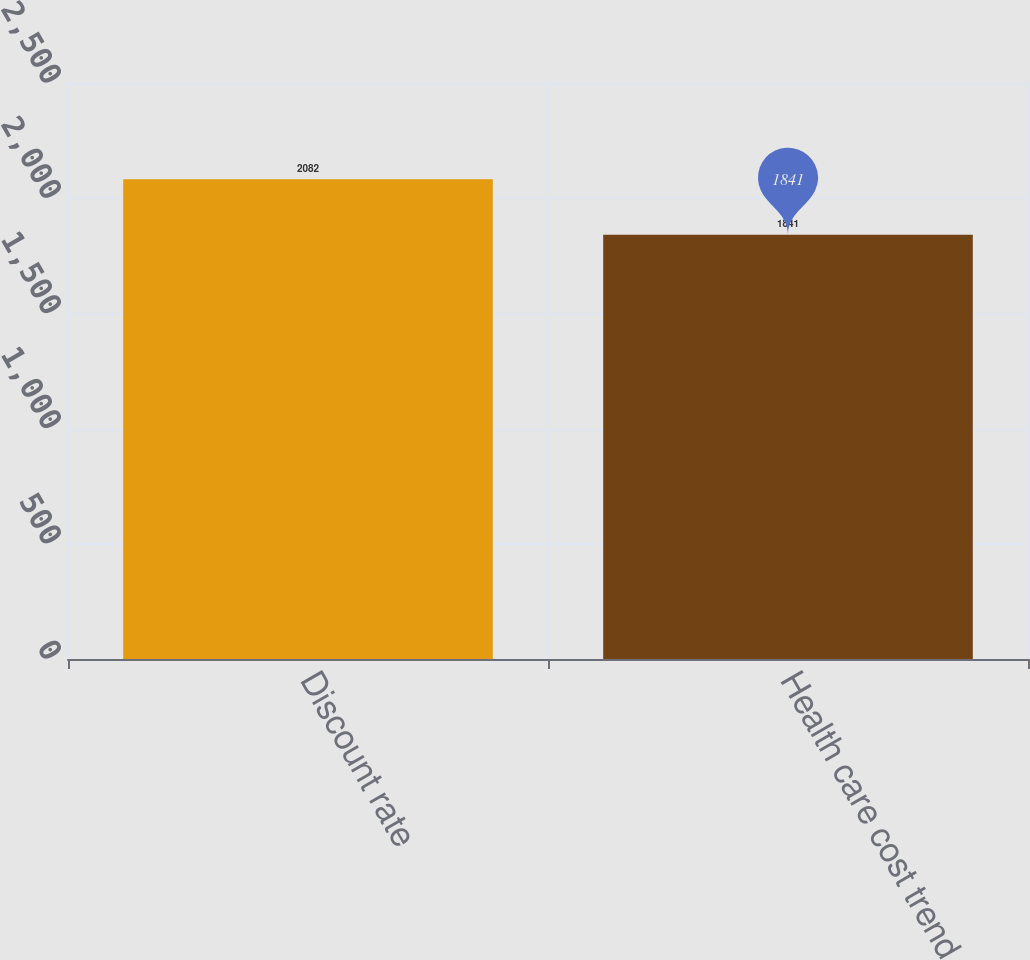Convert chart. <chart><loc_0><loc_0><loc_500><loc_500><bar_chart><fcel>Discount rate<fcel>Health care cost trend<nl><fcel>2082<fcel>1841<nl></chart> 